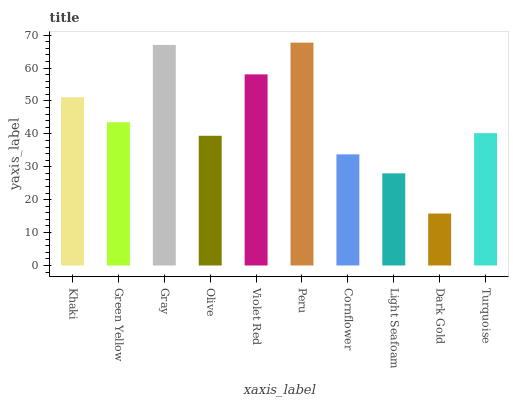Is Green Yellow the minimum?
Answer yes or no. No. Is Green Yellow the maximum?
Answer yes or no. No. Is Khaki greater than Green Yellow?
Answer yes or no. Yes. Is Green Yellow less than Khaki?
Answer yes or no. Yes. Is Green Yellow greater than Khaki?
Answer yes or no. No. Is Khaki less than Green Yellow?
Answer yes or no. No. Is Green Yellow the high median?
Answer yes or no. Yes. Is Turquoise the low median?
Answer yes or no. Yes. Is Light Seafoam the high median?
Answer yes or no. No. Is Light Seafoam the low median?
Answer yes or no. No. 